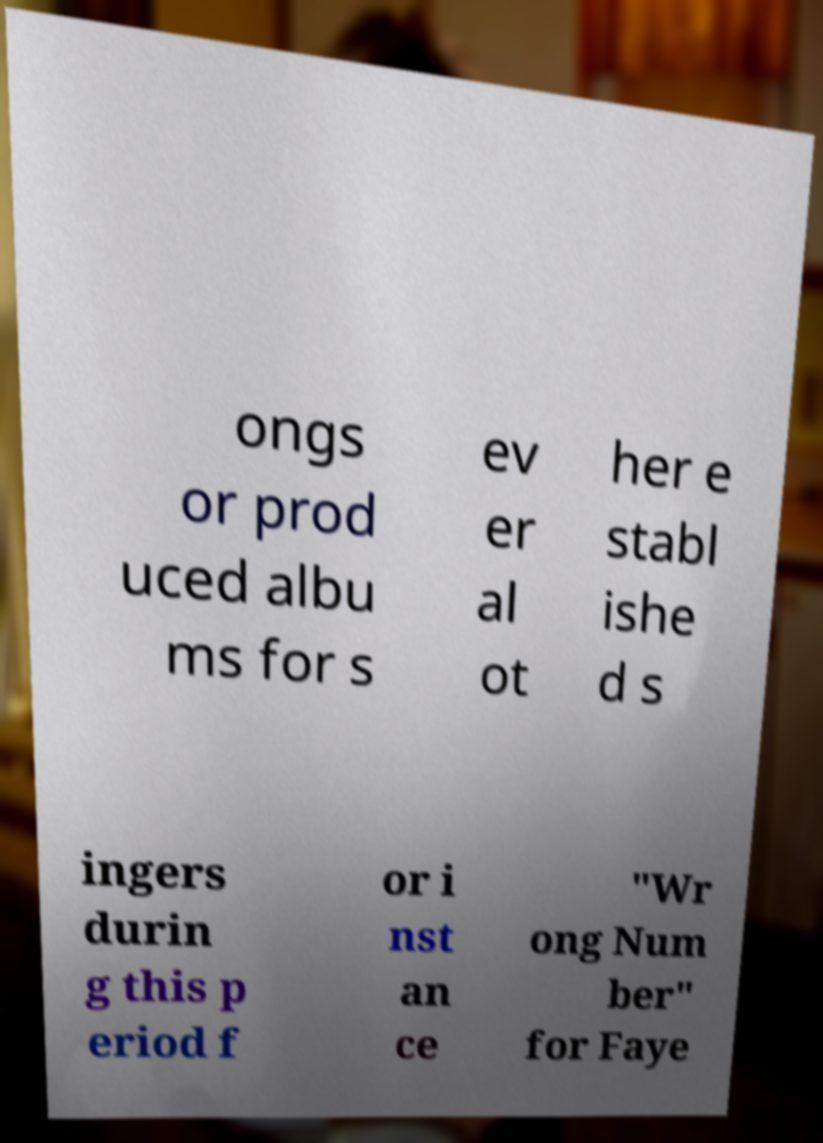There's text embedded in this image that I need extracted. Can you transcribe it verbatim? ongs or prod uced albu ms for s ev er al ot her e stabl ishe d s ingers durin g this p eriod f or i nst an ce "Wr ong Num ber" for Faye 